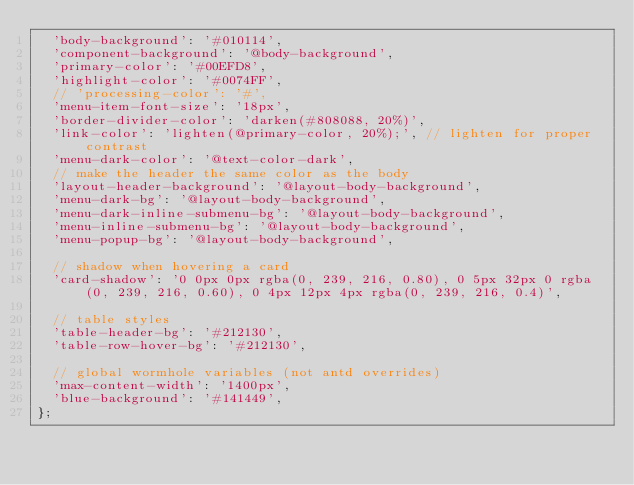Convert code to text. <code><loc_0><loc_0><loc_500><loc_500><_JavaScript_>  'body-background': '#010114',
  'component-background': '@body-background',
  'primary-color': '#00EFD8',
  'highlight-color': '#0074FF',
  // 'processing-color': '#',
  'menu-item-font-size': '18px',
  'border-divider-color': 'darken(#808088, 20%)',
  'link-color': 'lighten(@primary-color, 20%);', // lighten for proper contrast
  'menu-dark-color': '@text-color-dark',
  // make the header the same color as the body
  'layout-header-background': '@layout-body-background',
  'menu-dark-bg': '@layout-body-background',
  'menu-dark-inline-submenu-bg': '@layout-body-background',
  'menu-inline-submenu-bg': '@layout-body-background',
  'menu-popup-bg': '@layout-body-background',

  // shadow when hovering a card
  'card-shadow': '0 0px 0px rgba(0, 239, 216, 0.80), 0 5px 32px 0 rgba(0, 239, 216, 0.60), 0 4px 12px 4px rgba(0, 239, 216, 0.4)',

  // table styles
  'table-header-bg': '#212130',
  'table-row-hover-bg': '#212130',

  // global wormhole variables (not antd overrides)
  'max-content-width': '1400px',
  'blue-background': '#141449',
};
</code> 